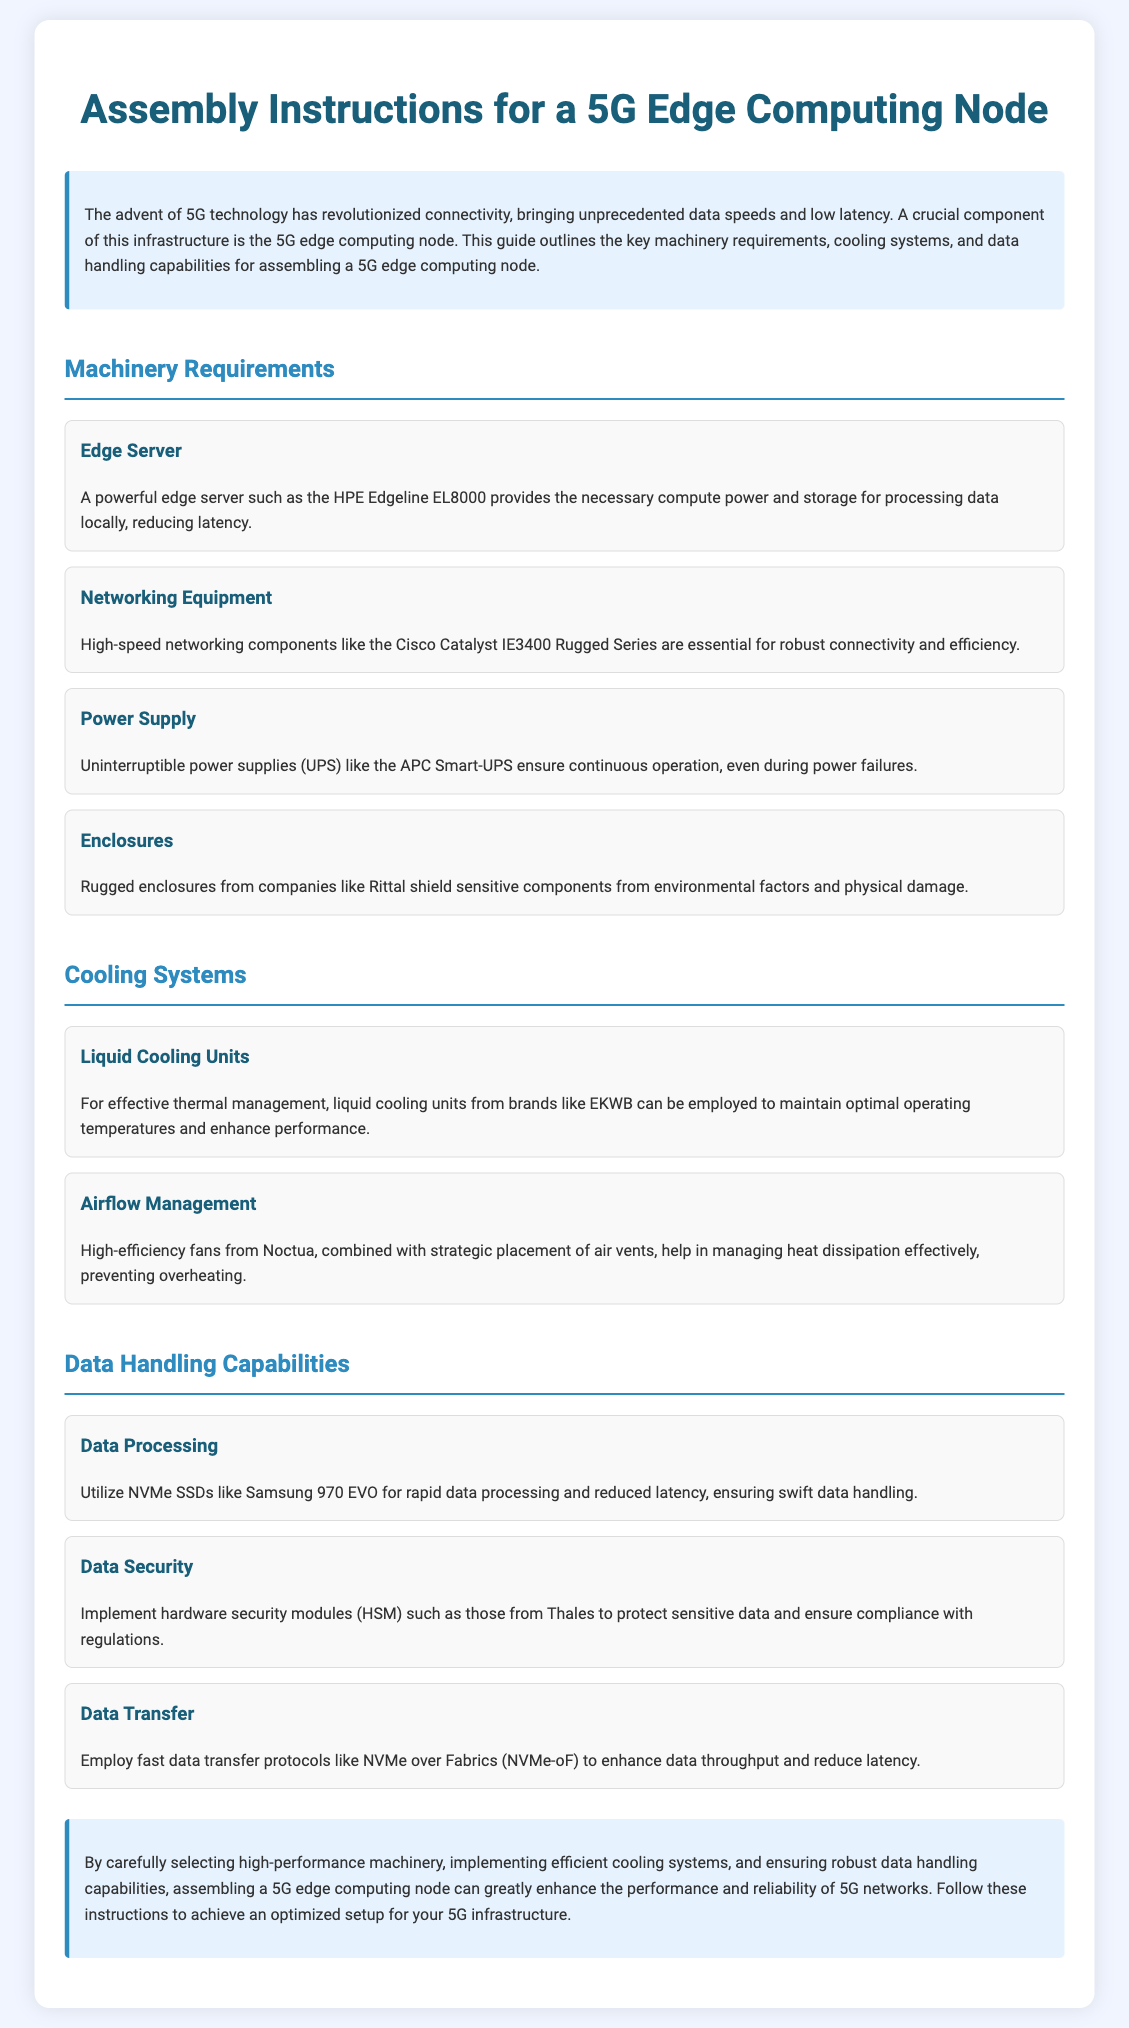what is the edge server mentioned in the document? The edge server mentioned in the document is the HPE Edgeline EL8000, which provides the necessary compute power and storage for processing data locally.
Answer: HPE Edgeline EL8000 which networking equipment is required? The required networking equipment highlighted in the document is the Cisco Catalyst IE3400 Rugged Series, which is essential for robust connectivity and efficiency.
Answer: Cisco Catalyst IE3400 Rugged Series what type of power supply is recommended? The recommended power supply mentioned in the document is an Uninterruptible Power Supply (UPS) like the APC Smart-UPS, which ensures continuous operation during power failures.
Answer: APC Smart-UPS name a cooling system mentioned in the document. A type of cooling system mentioned in the document is liquid cooling units from brands like EKWB, which help maintain optimal operating temperatures.
Answer: EKWB what is used for data processing in the 5G edge node? The document states that NVMe SSDs such as Samsung 970 EVO are utilized for rapid data processing and reduced latency.
Answer: Samsung 970 EVO what is the purpose of hardware security modules? The purpose of hardware security modules mentioned in the document is to protect sensitive data and ensure compliance with regulations.
Answer: Protect sensitive data name a fast data transfer protocol mentioned. The fast data transfer protocol mentioned in the document is NVMe over Fabrics (NVMe-oF), which enhances data throughput and reduces latency.
Answer: NVMe over Fabrics what is a key requirement for effective thermal management? A key requirement for effective thermal management stated in the document is liquid cooling units, which maintain optimal operating temperatures.
Answer: Liquid cooling units what should be ensured for assembling a 5G edge computing node? The document emphasizes that high-performance machinery, efficient cooling systems, and robust data handling capabilities should be ensured for assembling a 5G edge computing node.
Answer: High-performance machinery 